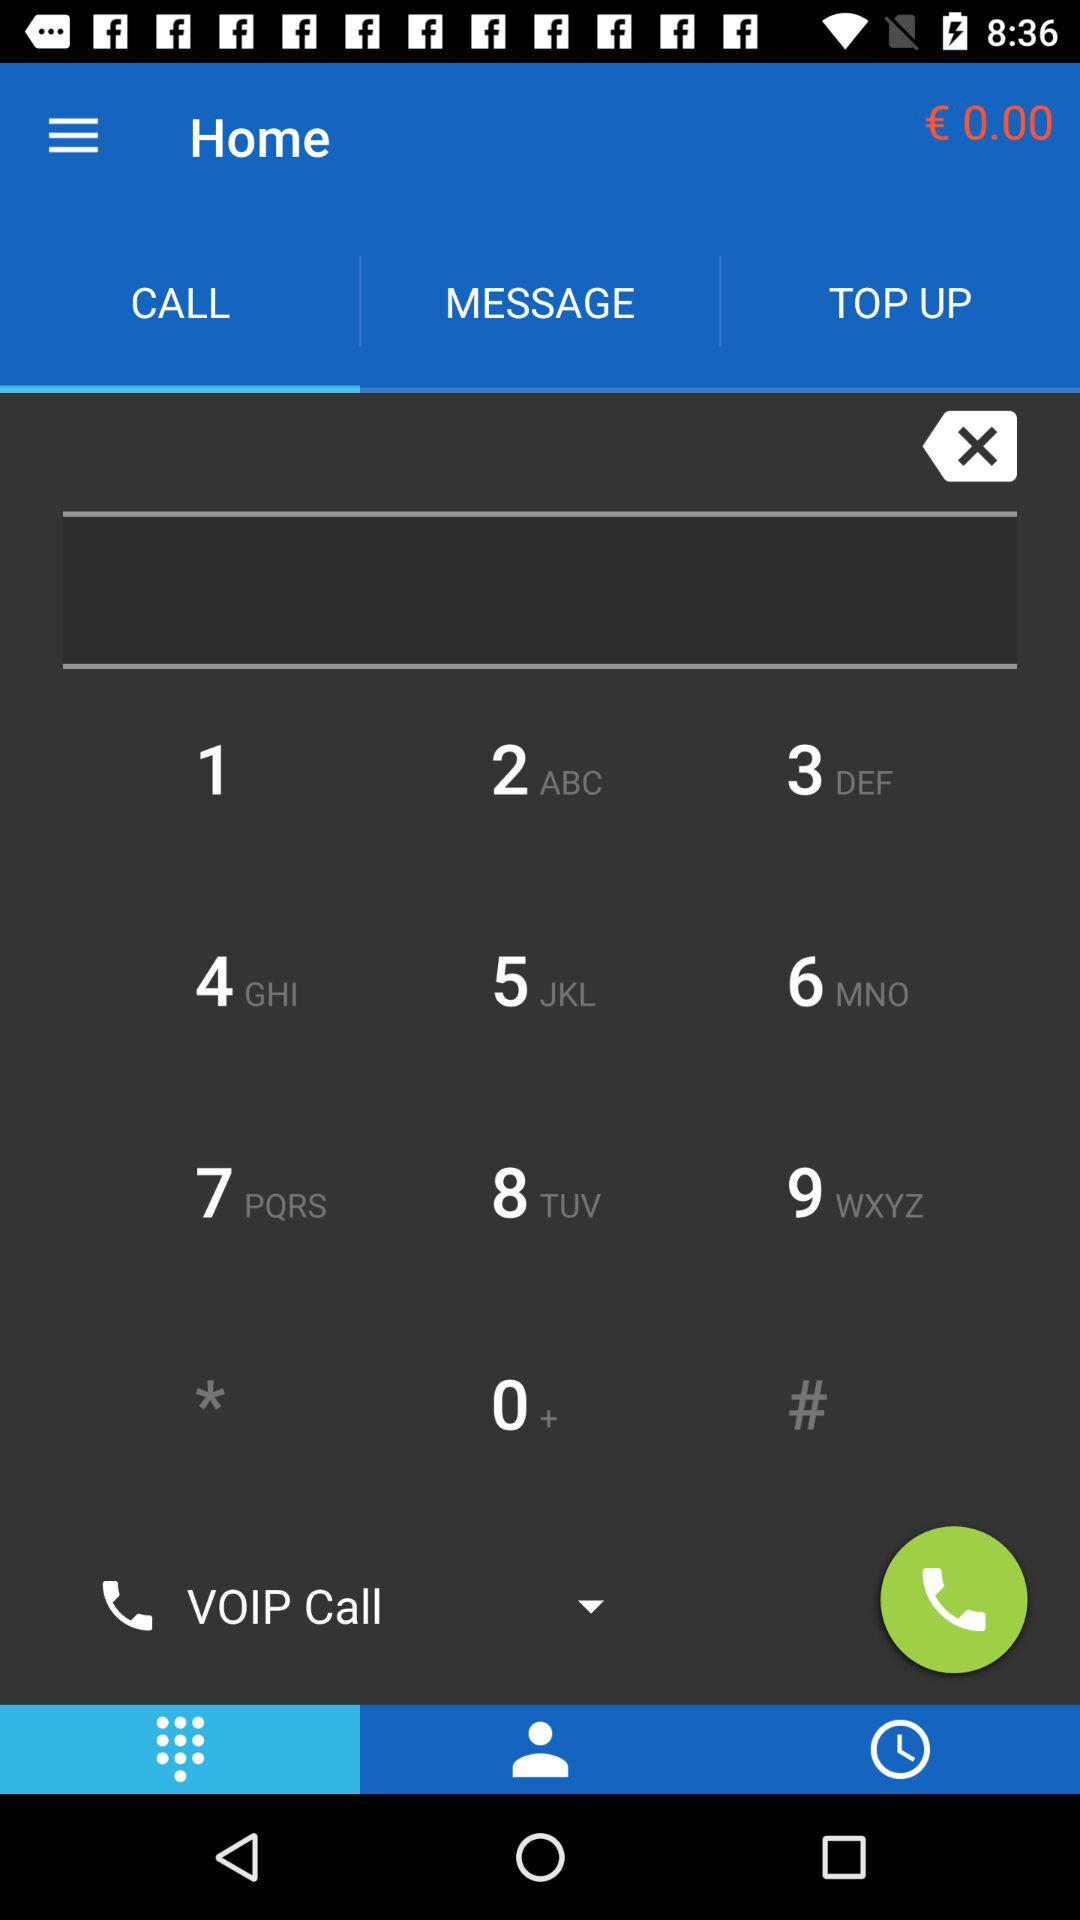What is the mentioned amount in euros? The mentioned amount in euros is zero. 